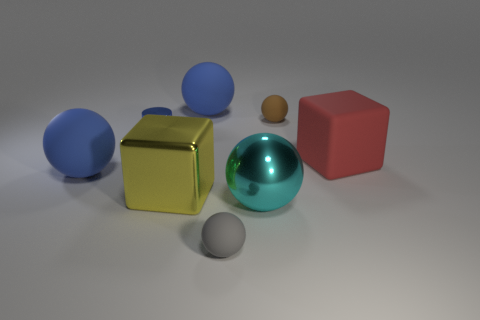What is the gray sphere made of?
Provide a short and direct response. Rubber. The large block that is the same material as the tiny blue cylinder is what color?
Your answer should be very brief. Yellow. Does the small brown thing have the same material as the blue ball behind the brown rubber ball?
Your answer should be very brief. Yes. How many gray balls are made of the same material as the tiny brown object?
Keep it short and to the point. 1. What is the shape of the small rubber thing that is in front of the small brown object?
Offer a very short reply. Sphere. Is the blue object behind the tiny blue object made of the same material as the gray sphere left of the big matte block?
Provide a short and direct response. Yes. Is there a red matte object of the same shape as the cyan metallic thing?
Your response must be concise. No. How many objects are either rubber balls that are in front of the tiny blue shiny thing or small cyan rubber things?
Offer a terse response. 2. Are there more cyan objects that are on the left side of the large red rubber thing than cubes to the left of the blue shiny object?
Your answer should be very brief. Yes. How many rubber objects are big purple cylinders or cyan spheres?
Ensure brevity in your answer.  0. 